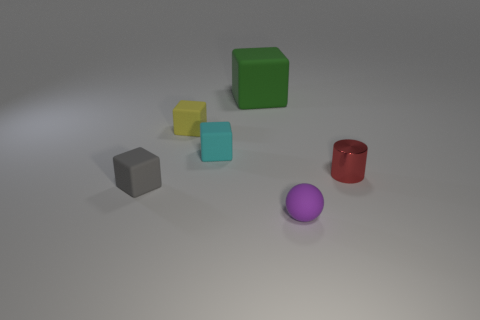What is the material of the gray object that is the same size as the shiny cylinder?
Provide a succinct answer. Rubber. There is a thing that is on the right side of the matte thing that is in front of the gray rubber thing; is there a gray block left of it?
Ensure brevity in your answer.  Yes. There is a cyan rubber object that is the same size as the gray rubber thing; what shape is it?
Your answer should be very brief. Cube. What material is the cylinder?
Your answer should be very brief. Metal. What number of other objects are there of the same material as the large green block?
Your answer should be very brief. 4. What is the size of the thing that is both behind the gray rubber cube and right of the big cube?
Provide a short and direct response. Small. What shape is the small thing to the right of the tiny purple rubber object that is in front of the yellow rubber object?
Make the answer very short. Cylinder. Is there anything else that has the same shape as the small gray object?
Provide a succinct answer. Yes. Are there the same number of small gray cubes that are behind the small cyan matte object and small cyan metallic cylinders?
Make the answer very short. Yes. Does the metal cylinder have the same color as the small object that is on the left side of the tiny yellow rubber thing?
Offer a very short reply. No. 